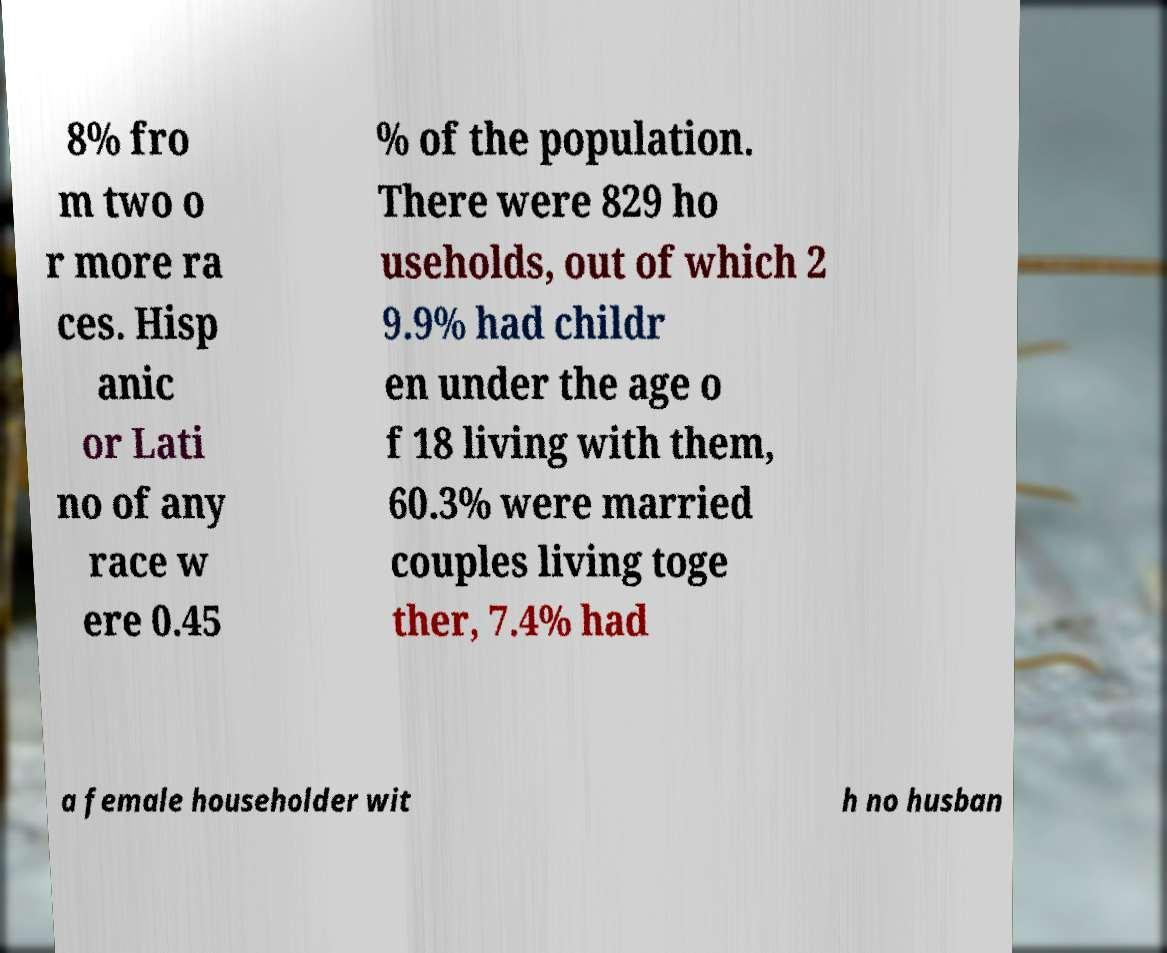For documentation purposes, I need the text within this image transcribed. Could you provide that? 8% fro m two o r more ra ces. Hisp anic or Lati no of any race w ere 0.45 % of the population. There were 829 ho useholds, out of which 2 9.9% had childr en under the age o f 18 living with them, 60.3% were married couples living toge ther, 7.4% had a female householder wit h no husban 